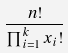Convert formula to latex. <formula><loc_0><loc_0><loc_500><loc_500>\frac { n ! } { \prod _ { i = 1 } ^ { k } x _ { i } ! }</formula> 